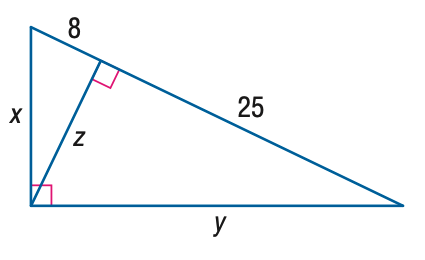Question: Find x.
Choices:
A. 8
B. 2 \sqrt { 34 }
C. 10 \sqrt { 2 }
D. 2 \sqrt { 66 }
Answer with the letter. Answer: D Question: Find y.
Choices:
A. 10 \sqrt { 2 }
B. 5 \sqrt { 17 }
C. 25
D. 5 \sqrt { 33 }
Answer with the letter. Answer: D 